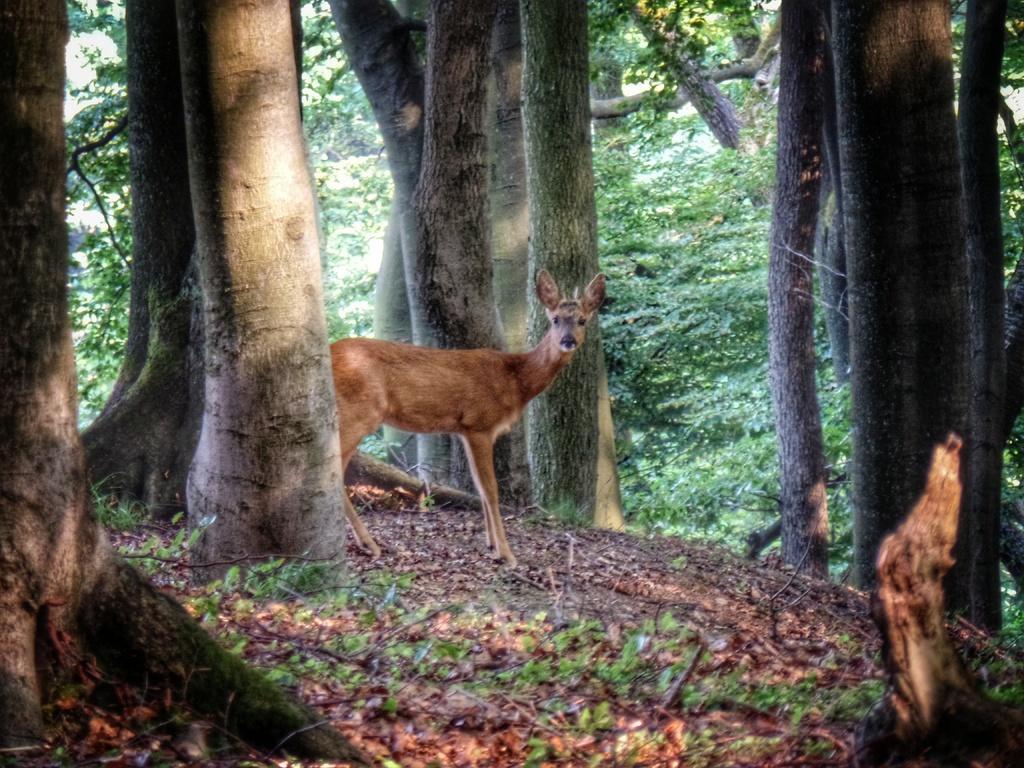Can you describe this image briefly? In this image we can see a deer standing on the ground. In the background we can see group of trees. 